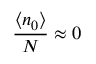Convert formula to latex. <formula><loc_0><loc_0><loc_500><loc_500>{ \frac { \langle n _ { 0 } \rangle } { N } } \approx 0</formula> 